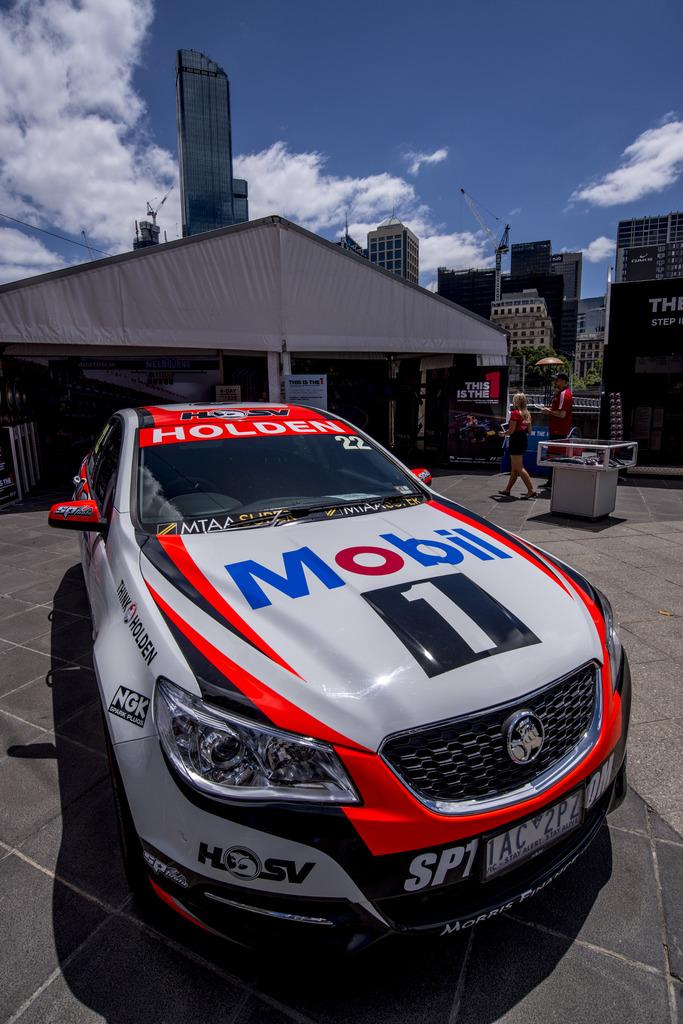What is the main subject of the picture? The main subject of the picture is a car. How can you describe the car in the picture? The car has a different color. What can be seen in the background of the picture? There are two persons walking and houses in the background of the picture. What is the condition of the sky in the background of the picture? The sky is clear in the background of the picture. Can you tell me how many corn stalks are growing in the background of the image? There is no corn or corn stalks present in the image; it features a car, people walking, houses, and a clear sky. What type of box is being used to store the ocean in the image? There is no box or ocean present in the image. 